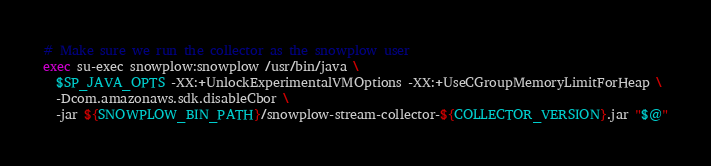Convert code to text. <code><loc_0><loc_0><loc_500><loc_500><_Bash_>
# Make sure we run the collector as the snowplow user
exec su-exec snowplow:snowplow /usr/bin/java \
  $SP_JAVA_OPTS -XX:+UnlockExperimentalVMOptions -XX:+UseCGroupMemoryLimitForHeap \
  -Dcom.amazonaws.sdk.disableCbor \
  -jar ${SNOWPLOW_BIN_PATH}/snowplow-stream-collector-${COLLECTOR_VERSION}.jar "$@"
</code> 